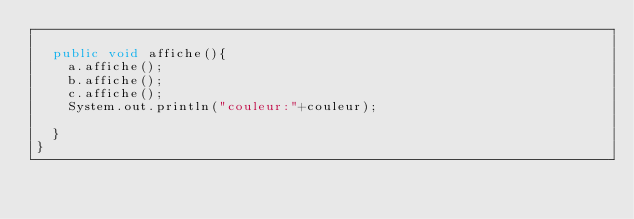<code> <loc_0><loc_0><loc_500><loc_500><_Java_>
	public void affiche(){
		a.affiche();
		b.affiche();
		c.affiche();
		System.out.println("couleur:"+couleur);

	}
}</code> 